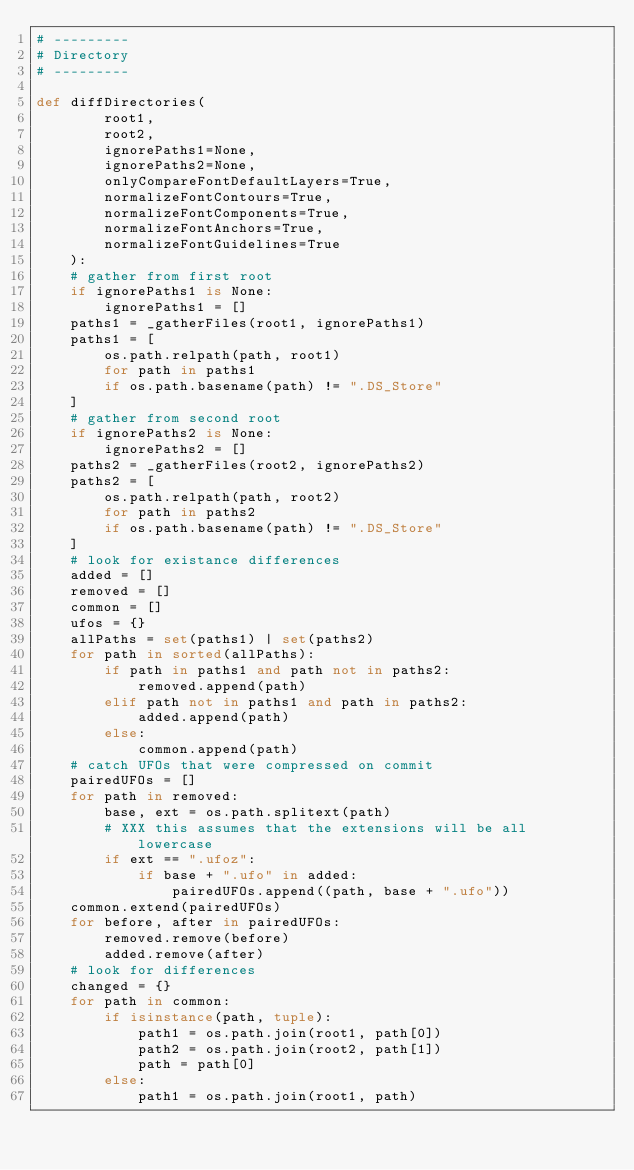<code> <loc_0><loc_0><loc_500><loc_500><_Python_># ---------
# Directory
# ---------

def diffDirectories(
        root1,
        root2,
        ignorePaths1=None,
        ignorePaths2=None,
        onlyCompareFontDefaultLayers=True,
        normalizeFontContours=True,
        normalizeFontComponents=True,
        normalizeFontAnchors=True,
        normalizeFontGuidelines=True
    ):
    # gather from first root
    if ignorePaths1 is None:
        ignorePaths1 = []
    paths1 = _gatherFiles(root1, ignorePaths1)
    paths1 = [
        os.path.relpath(path, root1)
        for path in paths1
        if os.path.basename(path) != ".DS_Store"
    ]
    # gather from second root
    if ignorePaths2 is None:
        ignorePaths2 = []
    paths2 = _gatherFiles(root2, ignorePaths2)
    paths2 = [
        os.path.relpath(path, root2)
        for path in paths2
        if os.path.basename(path) != ".DS_Store"
    ]
    # look for existance differences
    added = []
    removed = []
    common = []
    ufos = {}
    allPaths = set(paths1) | set(paths2)
    for path in sorted(allPaths):
        if path in paths1 and path not in paths2:
            removed.append(path)
        elif path not in paths1 and path in paths2:
            added.append(path)
        else:
            common.append(path)
    # catch UFOs that were compressed on commit
    pairedUFOs = []
    for path in removed:
        base, ext = os.path.splitext(path)
        # XXX this assumes that the extensions will be all lowercase
        if ext == ".ufoz":
            if base + ".ufo" in added:
                pairedUFOs.append((path, base + ".ufo"))
    common.extend(pairedUFOs)
    for before, after in pairedUFOs:
        removed.remove(before)
        added.remove(after)
    # look for differences
    changed = {}
    for path in common:
        if isinstance(path, tuple):
            path1 = os.path.join(root1, path[0])
            path2 = os.path.join(root2, path[1])
            path = path[0]
        else:
            path1 = os.path.join(root1, path)</code> 